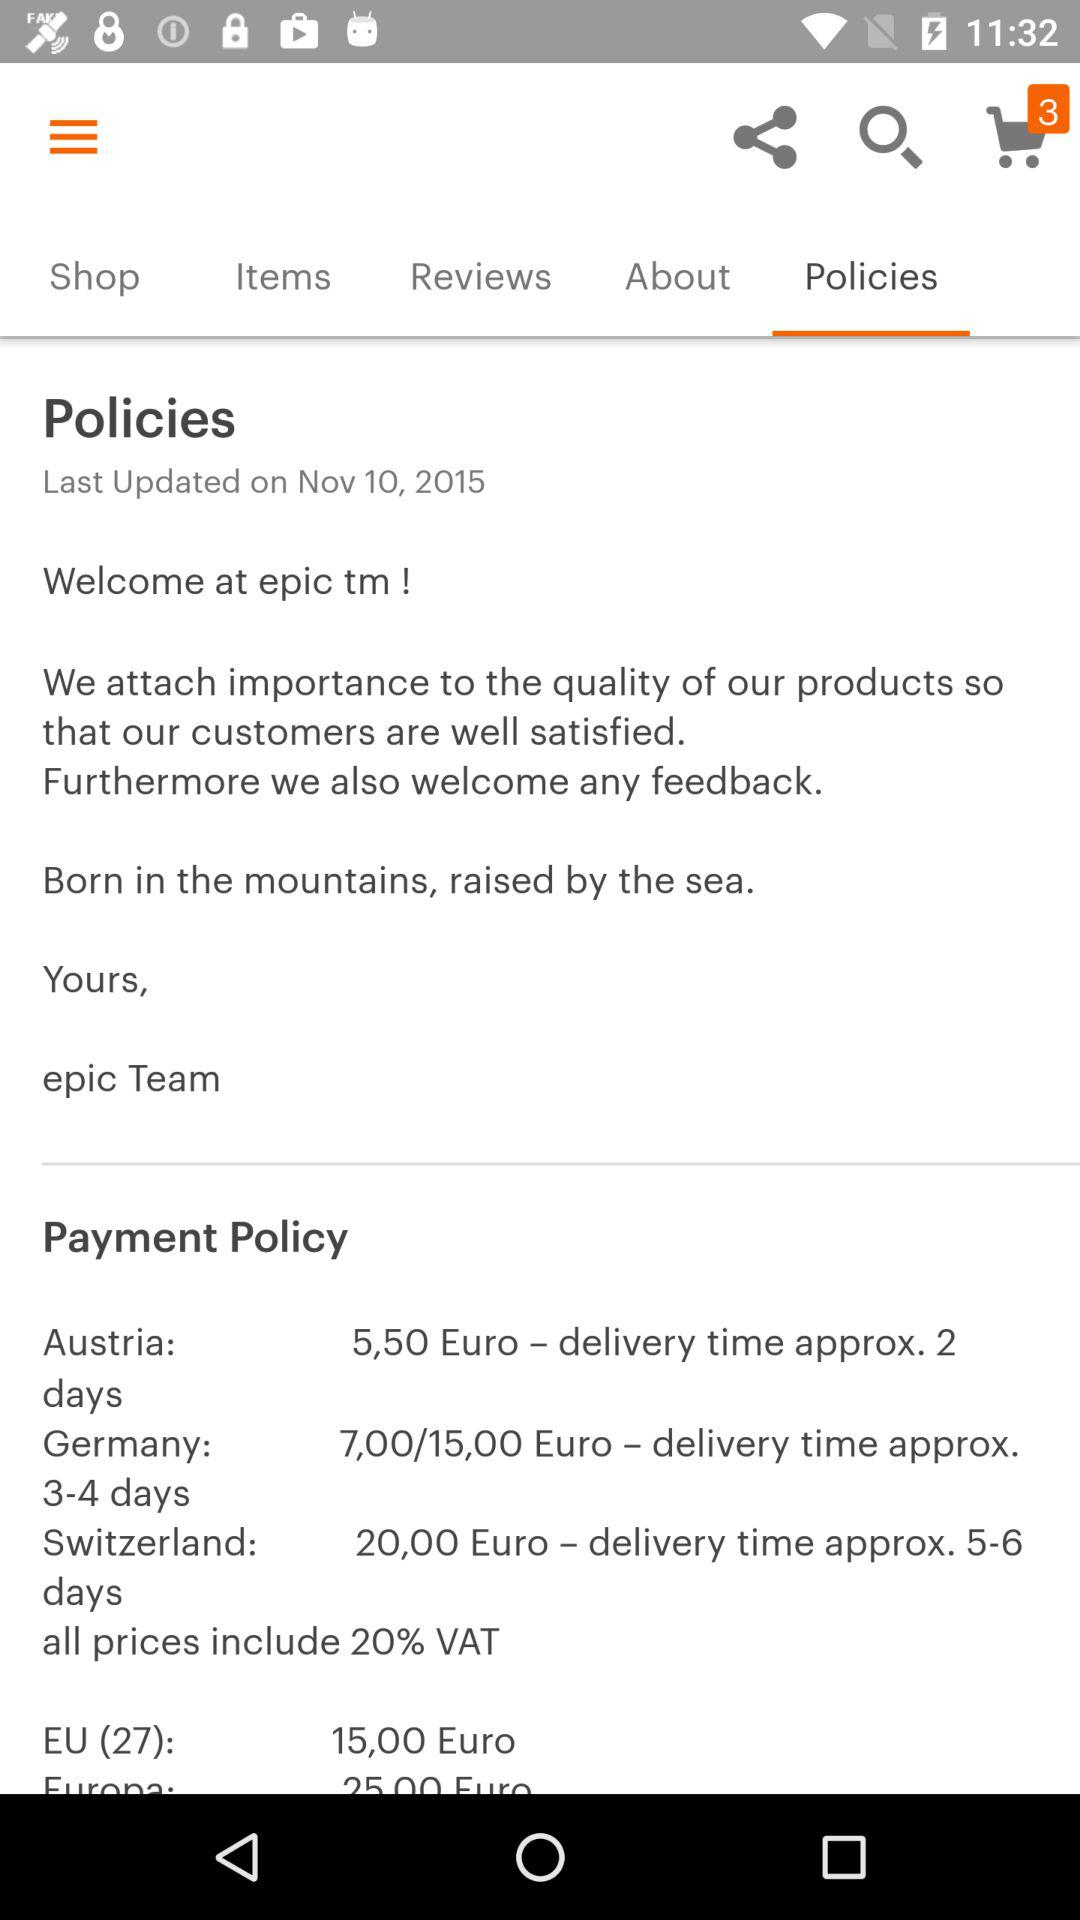What is the selected tab? The selected tab is "Policies". 